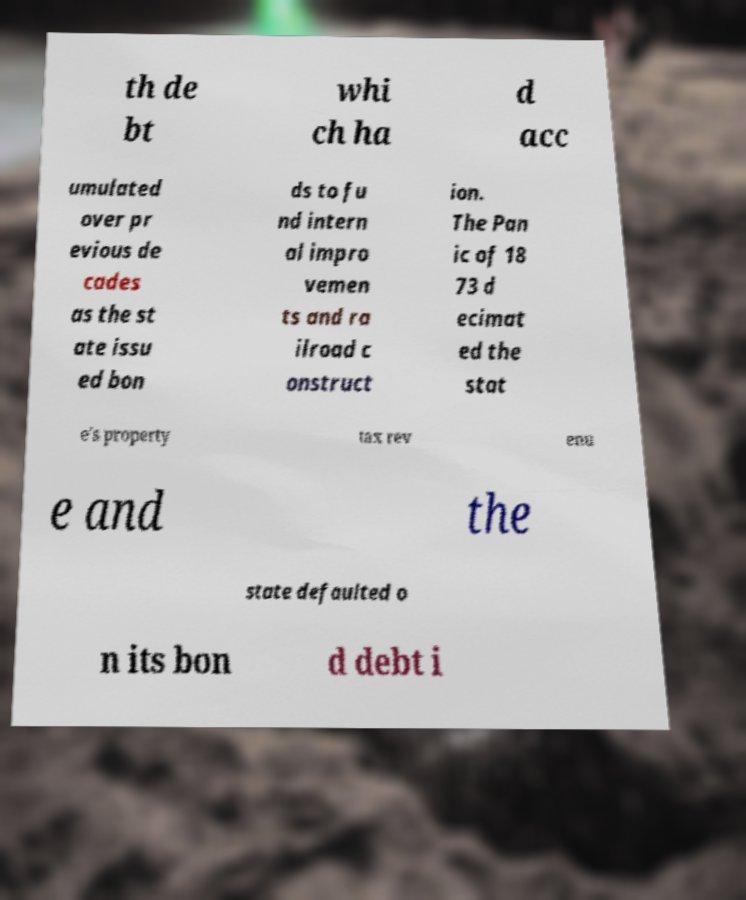Can you read and provide the text displayed in the image?This photo seems to have some interesting text. Can you extract and type it out for me? th de bt whi ch ha d acc umulated over pr evious de cades as the st ate issu ed bon ds to fu nd intern al impro vemen ts and ra ilroad c onstruct ion. The Pan ic of 18 73 d ecimat ed the stat e's property tax rev enu e and the state defaulted o n its bon d debt i 